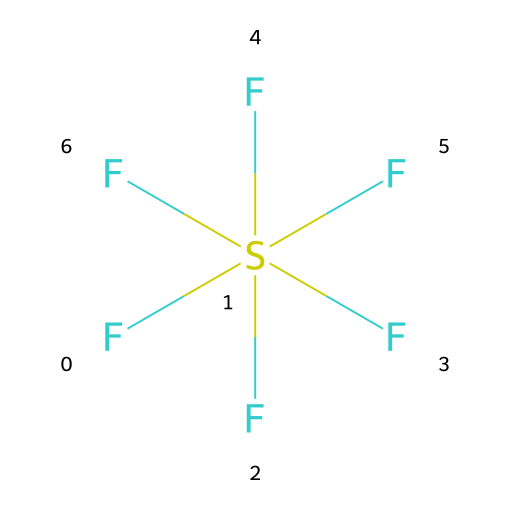What is the name of this compound? The SMILES representation indicates the presence of sulfur (S) and fluorine (F) atoms, and there is a common name associated with the structure that has six fluorine atoms attached to a sulfur atom. Thus, the compound is known as sulfur hexafluoride.
Answer: sulfur hexafluoride How many fluorine atoms are present in this compound? By examining the SMILES representation, we can count the number of 'F' atoms attached to the sulfur atom. There are six fluorine atoms indicated in the structure.
Answer: six What type of bonds are present between sulfur and fluorine? The SMILES notation shows that each fluorine atom is directly bonded to the sulfur atom without any indication of multiple bonds, suggesting that these are single covalent bonds.
Answer: single covalent Is sulfur hexafluoride a polar or nonpolar molecule? To determine polarity, we consider the symmetrical arrangement of the six fluorine atoms around the sulfur atom, which results in a nonpolar molecule, as the dipoles cancel out.
Answer: nonpolar What is the molecular geometry of sulfur hexafluoride? The arrangement of six fluorine atoms around a single sulfur atom suggests an octahedral geometry due to the six bond pairs of electrons, which aligns with the VSEPR theory.
Answer: octahedral How does sulfur hexafluoride contribute to greenhouse gas effects? Though sulfur hexafluoride is a greenhouse gas, its contribution is not due to a higher concentration but because it has a very high global warming potential compared to carbon dioxide, making it a potent greenhouse gas despite low atmospheric levels.
Answer: potent What is the significance of sulfur hexafluoride in electrical insulation? Sulfur hexafluoride is used in high-voltage electrical systems as an insulating and arc-extinguishing medium due to its high dielectric strength, which helps prevent electrical discharges.
Answer: insulation 